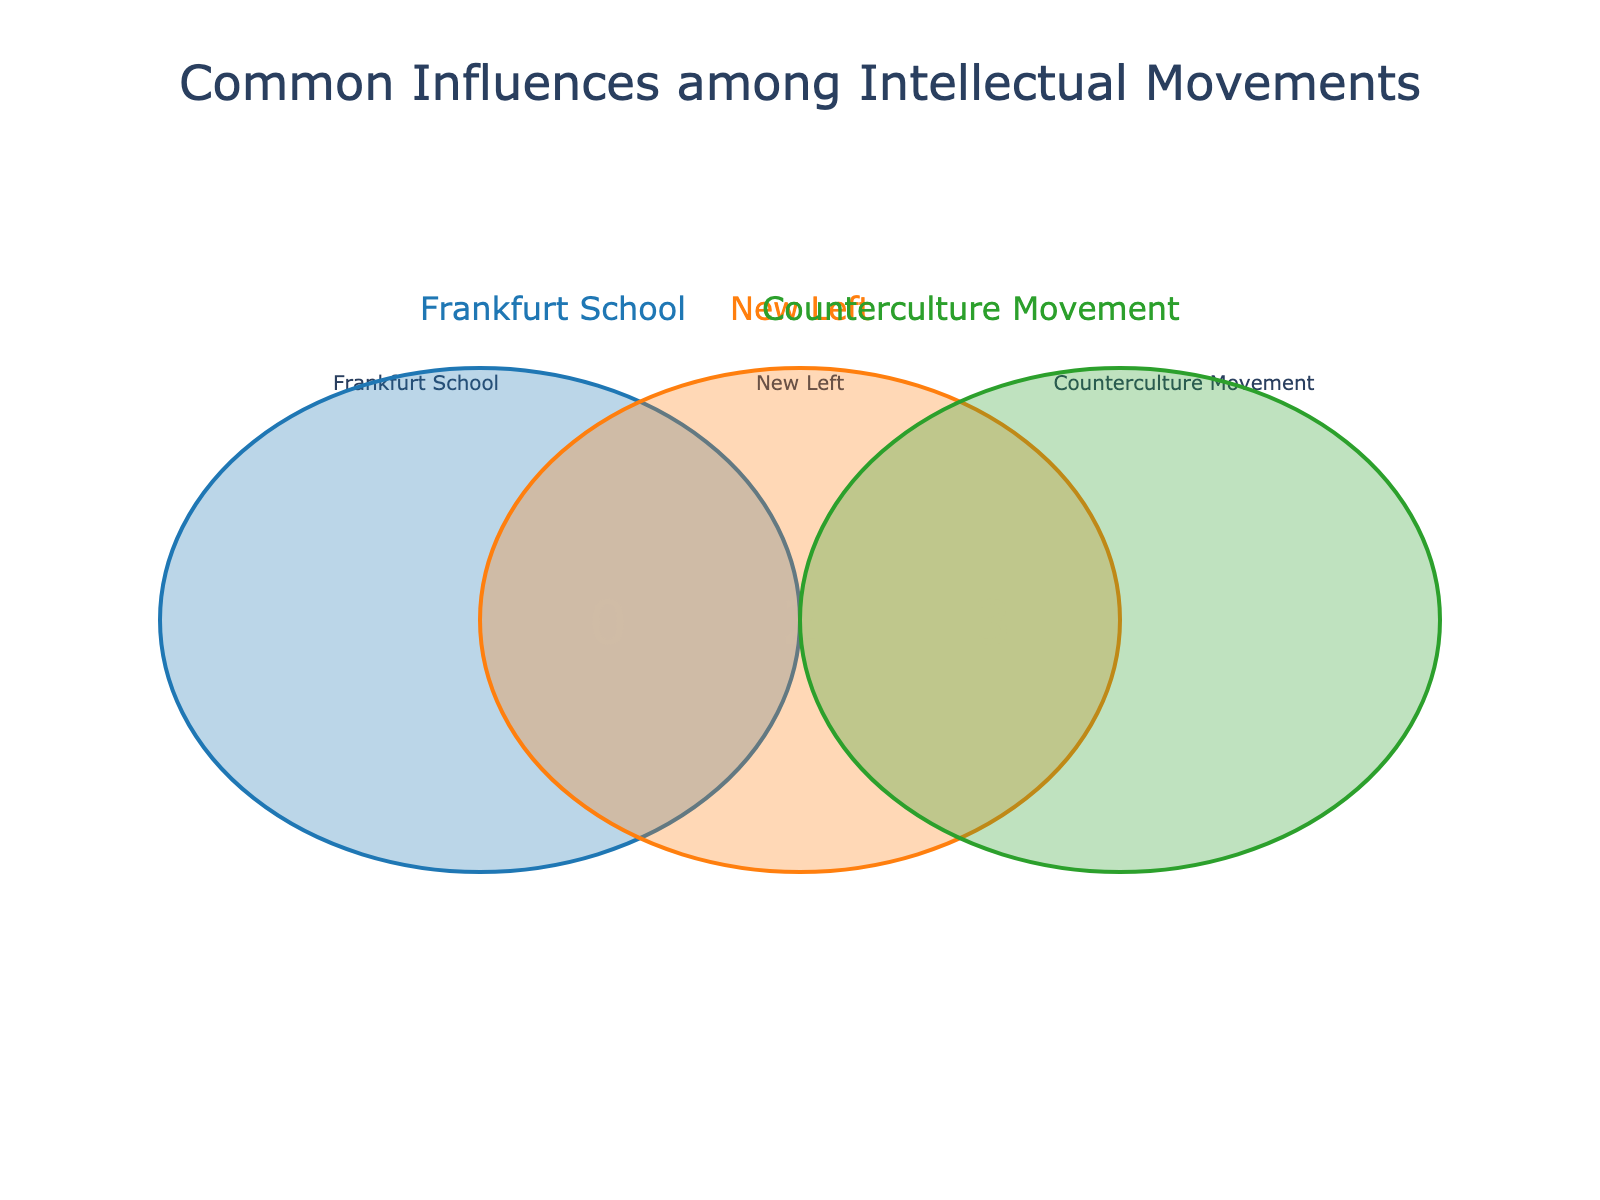What is the title of the figure? The title is usually displayed at the top of the figure. Here, it reads "Common Influences among Intellectual Movements".
Answer: Common Influences among Intellectual Movements How many unique influences are shared among the Frankfurt School and the New Left but not the Counterculture Movement? The number of items in the intersection of Frankfurt School and New Left, excluding those also in the Counterculture Movement, is represented by the value of the overlap between the blue and orange circles. From the figure, it's visible as 1.
Answer: 1 Which intellectual movement shares the most unique elements? By examining the numbers within the individual circles, one can see which circle has the highest count. Here, Frankfurt School, New Left, and Counterculture Movement have their distinct elements counts highlighted as separate values. We can compare these values to determine this.
Answer: Counterculture Movement What are the influences that are common to all three intellectual movements? We look at the central overlap where all three circles intersect. This intersection will have the count for elements common to Frankfurt School, New Left, and Counterculture Movements. The figure shows the specific area where all three circles overlap.
Answer: Critical Theory, Critique of Capitalism How many influences are unique to the New Left intellectual movement? Unique influences for the New Left are counted within the orange circle, excluding overlaps with the blue and green circles. This is indicated by the number placed solely within the orange circle.
Answer: 4 Considering the overlaps, which intellectual movements share the influence of "Herbert Marcuse"? By looking at the Venn diagram, any influence that appears in the overlapping segments of the circles will help us identify which movements share it. "Herbert Marcuse" is present in the overlaps between Frankfurt School, New Left, and Counterculture Movement.
Answer: New Left and Counterculture Movement How many influences are shared between the New Left and the Counterculture Movement excluding the Frankfurt School? We look at the intersection of the New Left and Counterculture Movement circles, excluding their overlap with the Frankfurt School circle. The figure indicates this specific overlap with a number.
Answer: 3 Which intellectual movement appears to have the least amount of unique influences? By comparing the individual counts for each intellectual movement, we can see which one has the lowest number in its respective circle.
Answer: Frankfurt School How many unique influences does each intellectual movement contribute? Frankfurt School, New Left, and Counterculture Movement have their unique elements indicated by the numbers within their respective non-overlapping parts of the circles. By adding up these numbers, we get the required counts.
Answer: Frankfurt School: 3, New Left: 4, Counterculture Movement: 3 What is the total number of unique influences across all the intellectual movements? To get the total, we sum the counts in each individual circle and each overlap section, making sure not to double-count any overlaps. We use the individual and intersecting counts presented in the figure to calculate this.
Answer: 14 